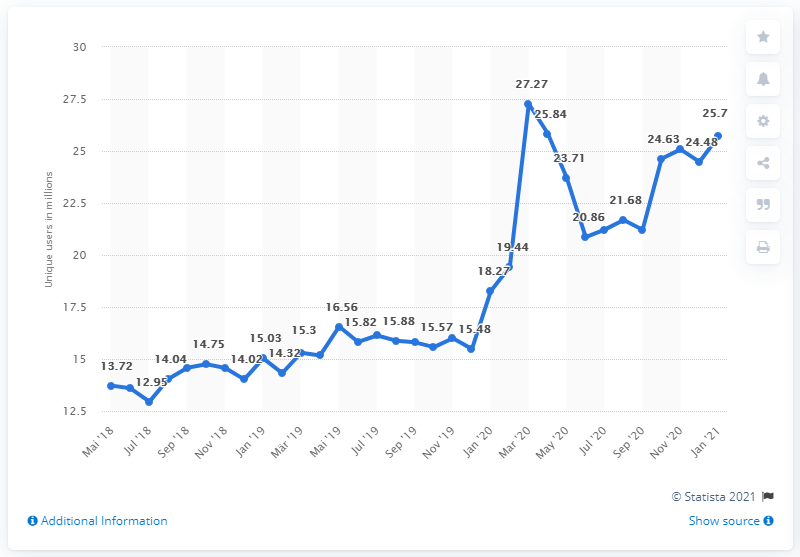List a handful of essential elements in this visual. In January 2021, the website n-tv.de was visited by 25,700 people. 